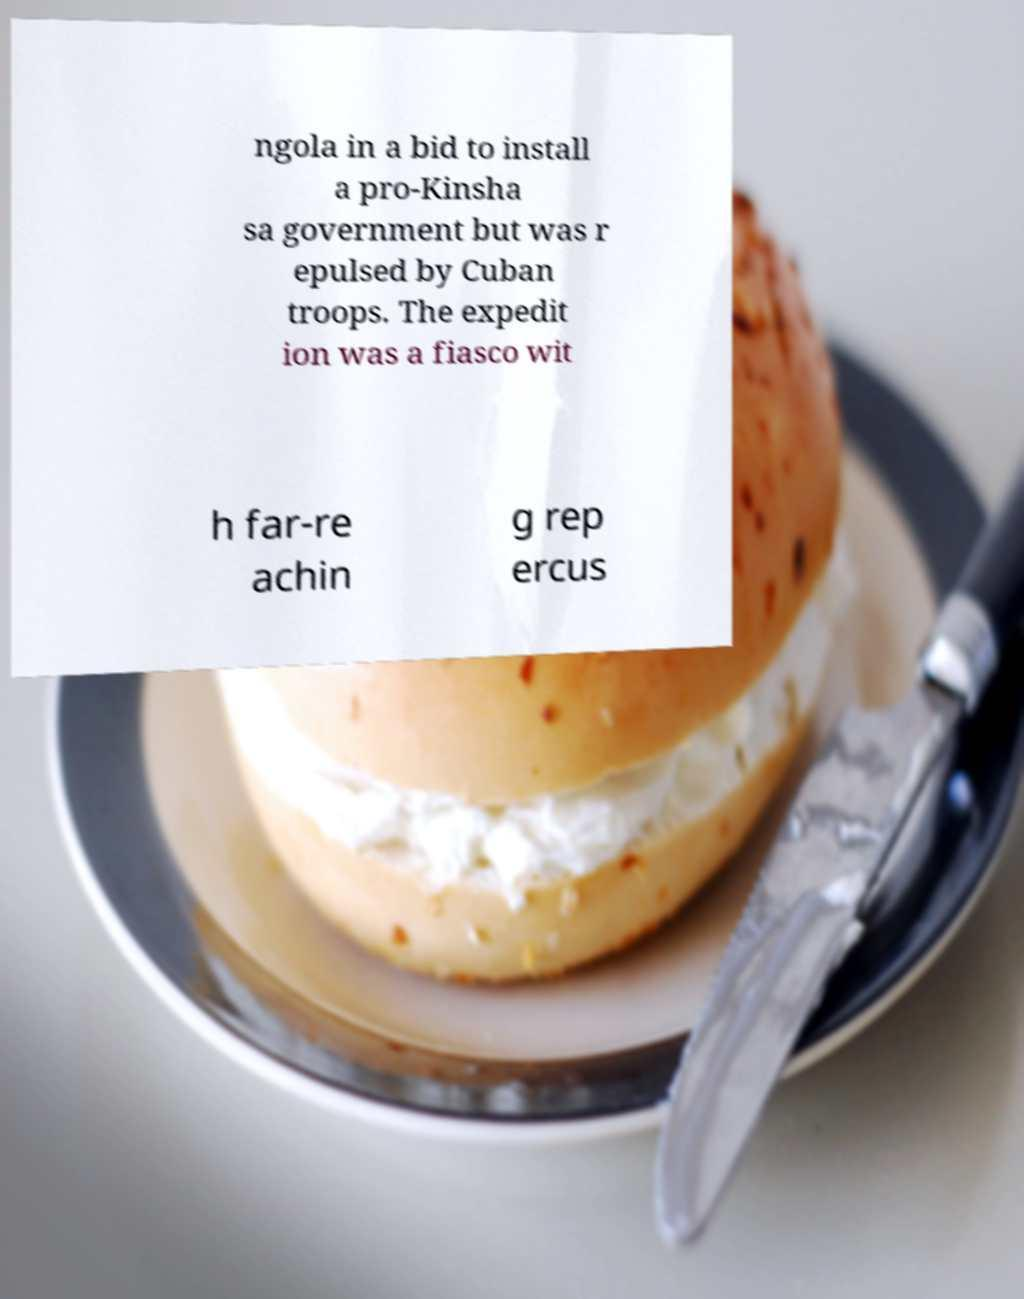Could you extract and type out the text from this image? ngola in a bid to install a pro-Kinsha sa government but was r epulsed by Cuban troops. The expedit ion was a fiasco wit h far-re achin g rep ercus 